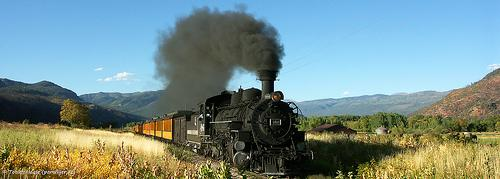Identify the natural element present in the background of the image. Mountains are present in the background of the image. Provide a brief description of the environment where the photo was taken. The photo was taken outdoors, with mountains in the background, dried tall grass, and a blue sky with white clouds. How many instances of smoke are visible in the image, and what colors are they? There are several instances of smoke in the image, with colors including gray and black. Describe the condition of the sky and the color of the clouds. The sky is blue in color with some clouds, and the clouds are white in color. What is the primary object in this image and what color is it? The primary object is a train, and it is black in color. What is the condition of the grass near the train way, and what color is it? The grass near the train way is dried out, brown, and tan-colored. What type of image analysis task can be used to identify the black train car and its location? Object detection task can be used to identify the black train car and its location. Explain what is happening with the train and its surrounding natural elements. The train is casting a shadow, with smoke coming out of it, and it is surrounded by dried tall grass and mountains in the background. What can be inferred about the weather in the image based on the sky and clouds? The weather seems to be clear and sunny, as the sky is blue with some white clouds. Can you count how many orange train cargos are present in the image? There are three orange train cargos in the image. What is the sentiment evoked by the image's grass? The sentiment evoked is dry and lifeless as the grass is described as short, tan-colored, and dried out. Determine the color of the sky in the image. The sky is blue in color. List all types of train-related objects mentioned in the image information. Train, train track, train cars, train smoke, black train car, orange train cargo, and part of a train. Provide a caption for the image based on the object at X:353, Y:135, width 143, and height 143. A field of tall, dried-out grass. Describe the interaction between the train and its environment. The train is casting a shadow, and smoke is coming off the train, affecting the surroundings. Find the pink unicorn in the top right corner of the image. This instruction includes a nonexistent object (pink unicorn) and a specific location (top right corner) in the image, misleading the reader to search for something that doesn't exist. It uses a declarative sentence to give instructions. Identify the object referred to as "a big green tree" and its location. The big green tree is located at X:58, Y:101, with width 43 and height 43. Detect any anomalies or unusual objects in the image. No anomalies or unusual objects detected. Is the grass in the image tall or short? The grass is short. Which item is likely to be heavy, considering the given information?  The heavy train smoke at X:218, Y:14, with width 67 and height 67 is likely to be heavy. What color is the front of the train located at X:167, Y:68 with width 151 and height 151? The front of the train is black in color. Identify the object and its location that represents the sky with clouds. The sky with clouds is located at X:303, Y:65, with width 47 and height 47. Provide a summary of the scenery depicted in the image. The image features an outdoor scene with a black train, dried-out grass, mountains in the background, and a blue sky with white clouds. Can you spot the red balloon floating above the train? This instruction introduces a nonexistent object (red balloon) and a relative location (floating above the train) that doesn't exist in the image. It uses an interrogative sentence to engage the reader in searching for the nonexistent object. Do you notice any flowers blooming in the tall grass? This instruction introduces a nonexistent element (flowers blooming) and a location (tall grass) that doesn't exist in the image. It uses an interrogative sentence to engage the reader in searching for something that isn't there. Locate a yellow school bus parked on the side of the train tracks. This instruction includes a nonexistent object (yellow school bus) and a location (on the side of the train tracks) that doesn't exist in the image. It uses a declarative sentence to give instructions, leading the reader to search for something not present. What is located at X:222, Y:30 with width 48 and height 48 in the image? A part of smoke. Assess the quality of the photo taken with dimensions X:2, Y:2, width 495, and height 495. The photo has strong composition and balanced lighting. Identify the object referred to as "these are clouds" in the image. The object is located at X:50, Y:55, with width 136 and height 136. Detect the attributes of the smoke coming from the train. The smoke is black and gray in color and may be heavy. Look for an airplane in the sky, just above the mountains. This instruction includes a nonexistent object (airplane) and a relative location (just above the mountains) that doesn't exist in the image. It uses a declarative sentence to mislead the reader into looking for something not present. Where can you see an orange train cargo in the image? An orange train cargo is located at X:151, Y:121, with width 26 and height 26. What does the object at X:302, Y:85 with width 28 and height 28 represent? The object represents white-colored clouds. What kind of objects are located at X:211, Y:115 with width 60 and height 60? A black car. Is there a group of people standing near the train tracks? This instruction introduces a nonexistent element (group of people) and a location (near the train tracks) that doesn't exist in the image. It uses an interrogative sentence to engage the reader in searching for something that isn't there. 